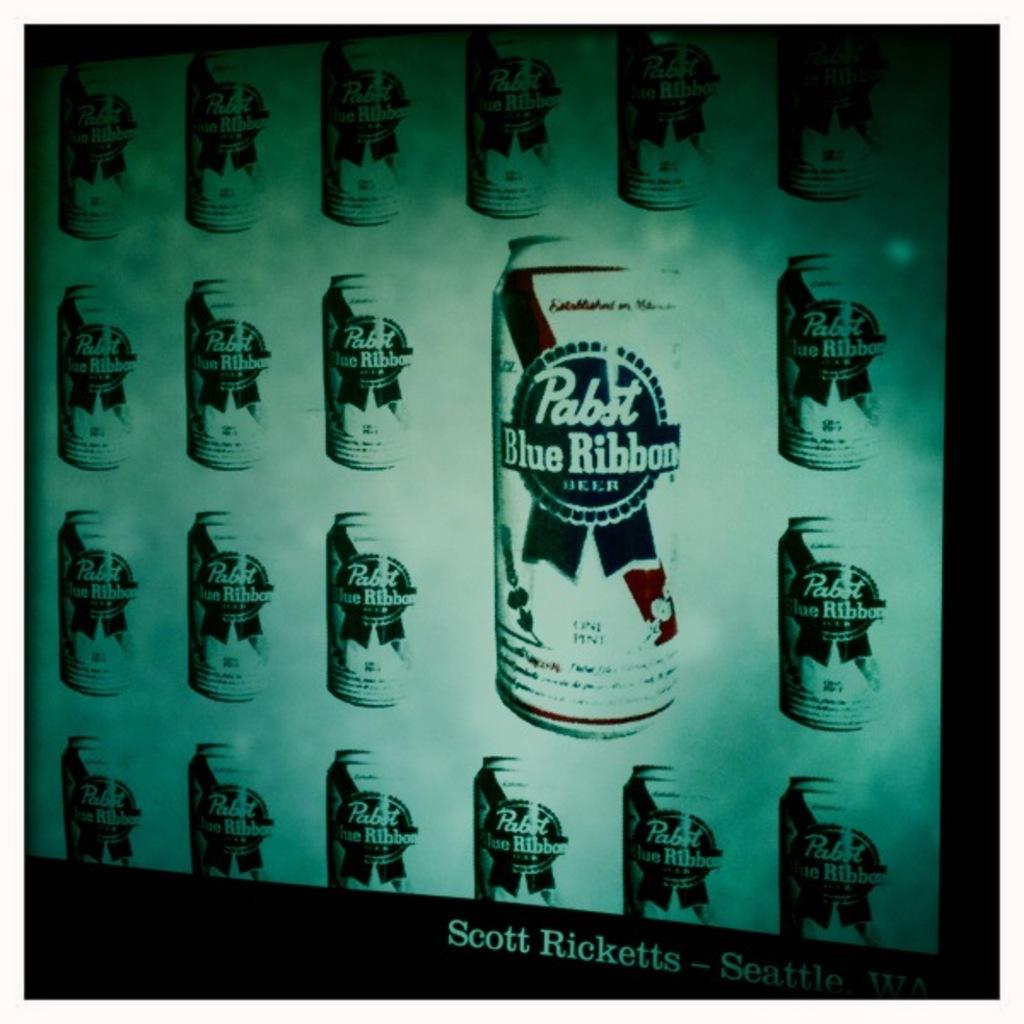What kind of beer is in these cans?
Keep it short and to the point. Pabst blue ribbon. Who made this work of art?
Make the answer very short. Scott ricketts. 